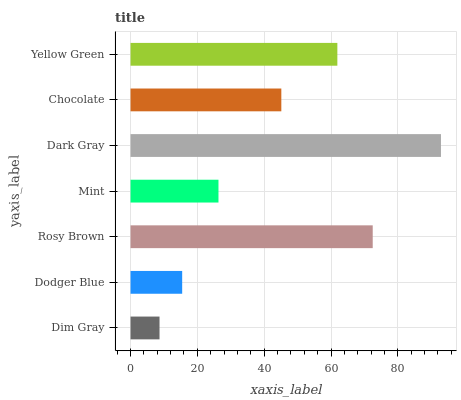Is Dim Gray the minimum?
Answer yes or no. Yes. Is Dark Gray the maximum?
Answer yes or no. Yes. Is Dodger Blue the minimum?
Answer yes or no. No. Is Dodger Blue the maximum?
Answer yes or no. No. Is Dodger Blue greater than Dim Gray?
Answer yes or no. Yes. Is Dim Gray less than Dodger Blue?
Answer yes or no. Yes. Is Dim Gray greater than Dodger Blue?
Answer yes or no. No. Is Dodger Blue less than Dim Gray?
Answer yes or no. No. Is Chocolate the high median?
Answer yes or no. Yes. Is Chocolate the low median?
Answer yes or no. Yes. Is Dim Gray the high median?
Answer yes or no. No. Is Rosy Brown the low median?
Answer yes or no. No. 